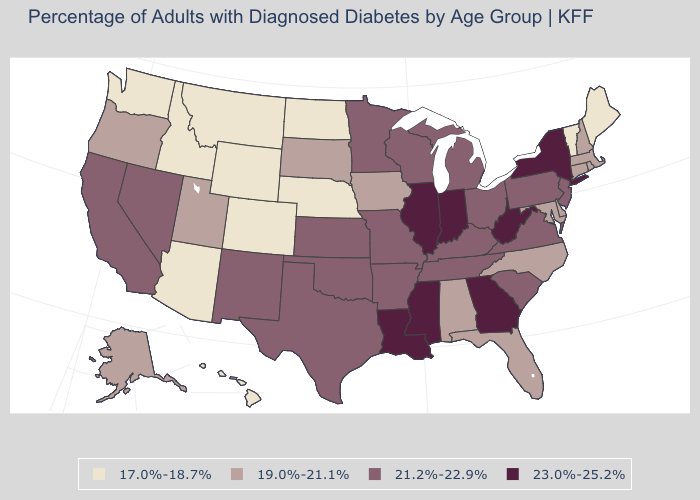What is the value of Vermont?
Short answer required. 17.0%-18.7%. What is the value of California?
Quick response, please. 21.2%-22.9%. Which states have the lowest value in the West?
Answer briefly. Arizona, Colorado, Hawaii, Idaho, Montana, Washington, Wyoming. Which states have the highest value in the USA?
Quick response, please. Georgia, Illinois, Indiana, Louisiana, Mississippi, New York, West Virginia. Among the states that border Delaware , does Maryland have the highest value?
Concise answer only. No. Does the map have missing data?
Concise answer only. No. Name the states that have a value in the range 17.0%-18.7%?
Write a very short answer. Arizona, Colorado, Hawaii, Idaho, Maine, Montana, Nebraska, North Dakota, Vermont, Washington, Wyoming. Among the states that border South Carolina , which have the highest value?
Be succinct. Georgia. What is the value of Pennsylvania?
Keep it brief. 21.2%-22.9%. Does the map have missing data?
Answer briefly. No. Which states have the highest value in the USA?
Concise answer only. Georgia, Illinois, Indiana, Louisiana, Mississippi, New York, West Virginia. Name the states that have a value in the range 23.0%-25.2%?
Concise answer only. Georgia, Illinois, Indiana, Louisiana, Mississippi, New York, West Virginia. What is the value of Kansas?
Be succinct. 21.2%-22.9%. Name the states that have a value in the range 21.2%-22.9%?
Write a very short answer. Arkansas, California, Kansas, Kentucky, Michigan, Minnesota, Missouri, Nevada, New Jersey, New Mexico, Ohio, Oklahoma, Pennsylvania, South Carolina, Tennessee, Texas, Virginia, Wisconsin. Among the states that border Indiana , does Michigan have the highest value?
Give a very brief answer. No. 